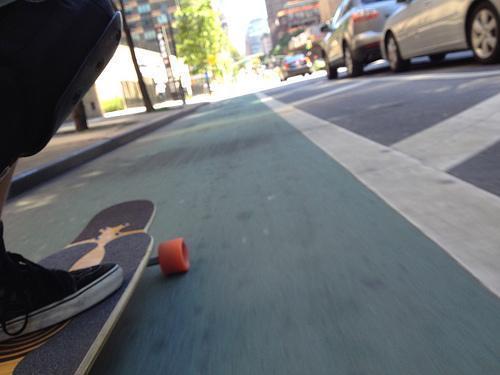How many skateboards are in the photo?
Give a very brief answer. 1. 